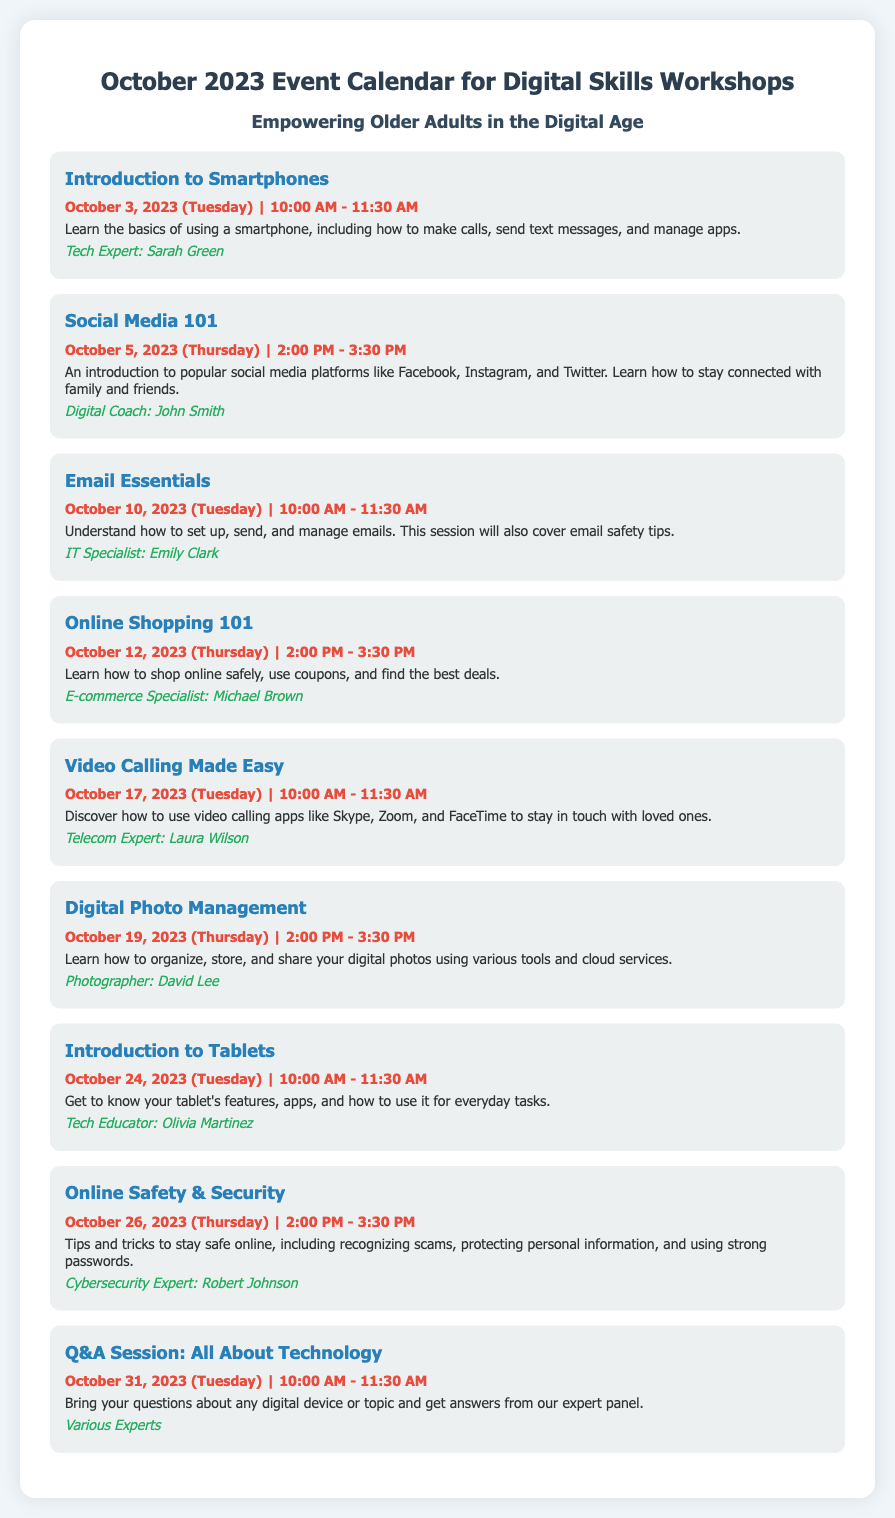what is the date for the "Introduction to Smartphones" workshop? The date for the "Introduction to Smartphones" workshop is mentioned in the document as October 3, 2023.
Answer: October 3, 2023 who is the presenter for "Email Essentials"? The document specifies that the presenter for "Email Essentials" is Emily Clark.
Answer: Emily Clark how long does each workshop session last? The durations for the workshops are consistently stated in the document as 1.5 hours (or 90 minutes).
Answer: 1.5 hours what is the main topic of the workshop on October 12? The main topic of the workshop on October 12 is specified as "Online Shopping 101."
Answer: Online Shopping 101 how many workshops are scheduled for October 2023? A count of the workshops listed in the document reveals that there are a total of 9 workshops scheduled for October 2023.
Answer: 9 workshops what is the focus of the "Online Safety & Security" session? The focus of the "Online Safety & Security" session as mentioned in the document is to provide tips and tricks to stay safe online.
Answer: Tips and tricks to stay safe online who are the presenters for the "Q&A Session: All About Technology"? The document states that the presenters for the "Q&A Session: All About Technology" are various experts.
Answer: Various Experts which workshop covers social media platforms? The workshop that covers social media platforms is titled "Social Media 101."
Answer: Social Media 101 